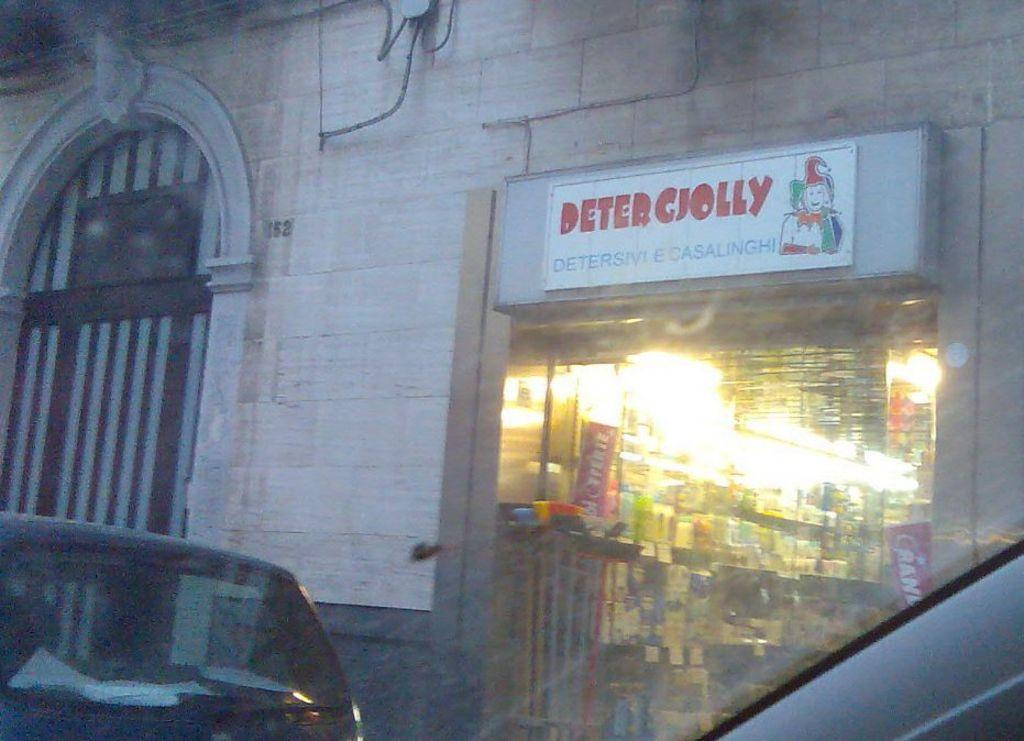What type of structure is visible in the image? There is a building in the image. What is located inside the building? Inside the building, there is a shop. What type of items can be found in the shop? The shop contains books and other things. Is there any vehicle visible in the image? Yes, there is a car in front of the building. What type of breakfast is being served in the image? There is no breakfast visible in the image; it features a building with a shop inside. What type of disease can be seen affecting the books in the image? There is no disease present in the image; the books appear to be in good condition. 